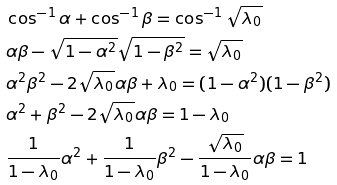Convert formula to latex. <formula><loc_0><loc_0><loc_500><loc_500>& \cos ^ { - 1 } \alpha + \cos ^ { - 1 } \beta = \cos ^ { - 1 } \sqrt { \lambda _ { 0 } } \\ & \alpha \beta - \sqrt { 1 - \alpha ^ { 2 } } \sqrt { 1 - \beta ^ { 2 } } = \sqrt { \lambda _ { 0 } } \\ & \alpha ^ { 2 } \beta ^ { 2 } - 2 \sqrt { \lambda _ { 0 } } \alpha \beta + \lambda _ { 0 } = ( 1 - \alpha ^ { 2 } ) ( 1 - \beta ^ { 2 } ) \\ & \alpha ^ { 2 } + \beta ^ { 2 } - 2 \sqrt { \lambda _ { 0 } } \alpha \beta = 1 - \lambda _ { 0 } \\ & \frac { 1 } { 1 - \lambda _ { 0 } } \alpha ^ { 2 } + \frac { 1 } { 1 - \lambda _ { 0 } } \beta ^ { 2 } - \frac { \sqrt { \lambda _ { 0 } } } { 1 - \lambda _ { 0 } } \alpha \beta = 1</formula> 